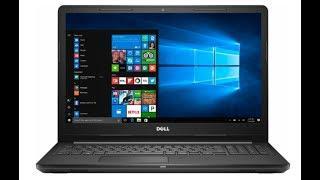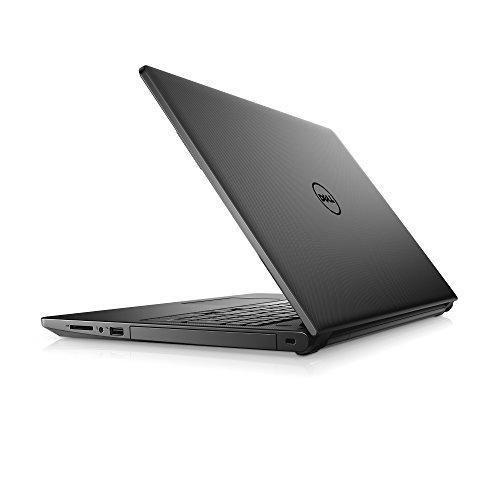The first image is the image on the left, the second image is the image on the right. For the images displayed, is the sentence "The back side of a laptop is visible in one of the images." factually correct? Answer yes or no. Yes. The first image is the image on the left, the second image is the image on the right. For the images displayed, is the sentence "All the laptops are fully open with visible screens." factually correct? Answer yes or no. No. 